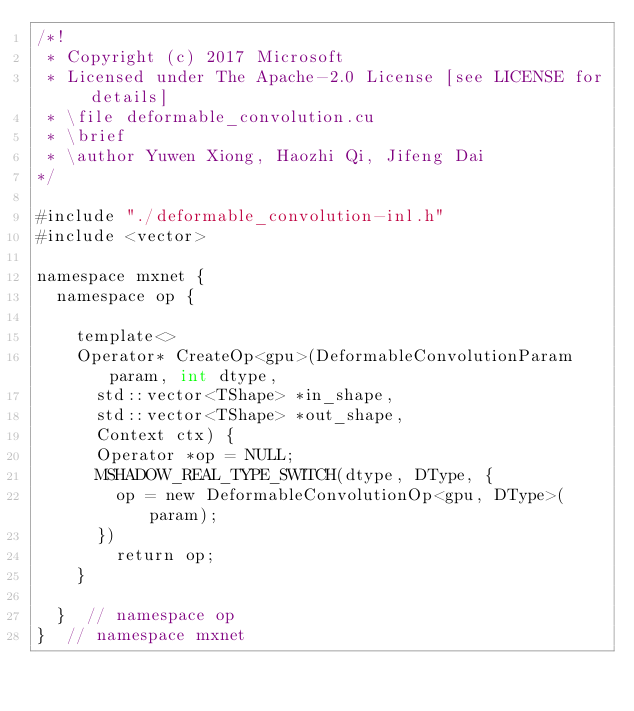Convert code to text. <code><loc_0><loc_0><loc_500><loc_500><_Cuda_>/*!
 * Copyright (c) 2017 Microsoft
 * Licensed under The Apache-2.0 License [see LICENSE for details]
 * \file deformable_convolution.cu
 * \brief
 * \author Yuwen Xiong, Haozhi Qi, Jifeng Dai
*/

#include "./deformable_convolution-inl.h"
#include <vector>

namespace mxnet {
  namespace op {

    template<>
    Operator* CreateOp<gpu>(DeformableConvolutionParam param, int dtype,
      std::vector<TShape> *in_shape,
      std::vector<TShape> *out_shape,
      Context ctx) {
      Operator *op = NULL;
      MSHADOW_REAL_TYPE_SWITCH(dtype, DType, {
        op = new DeformableConvolutionOp<gpu, DType>(param);
      })
        return op;
    }

  }  // namespace op
}  // namespace mxnet

</code> 